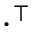Convert formula to latex. <formula><loc_0><loc_0><loc_500><loc_500>\cdot ^ { \intercal }</formula> 